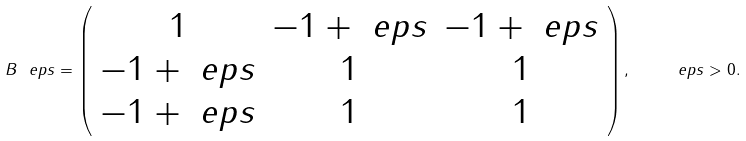<formula> <loc_0><loc_0><loc_500><loc_500>B _ { \ } e p s = \left ( \begin{array} { c c c } 1 & - 1 + \ e p s & - 1 + \ e p s \\ - 1 + \ e p s & 1 & 1 \\ - 1 + \ e p s & 1 & 1 \end{array} \right ) , \quad \ e p s > 0 .</formula> 